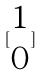Convert formula to latex. <formula><loc_0><loc_0><loc_500><loc_500>[ \begin{matrix} 1 \\ 0 \end{matrix} ]</formula> 